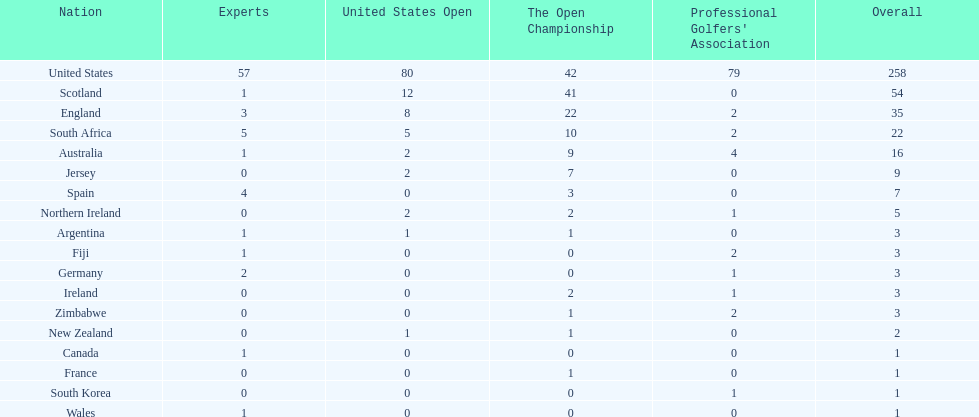Which country has the most pga championships. United States. 